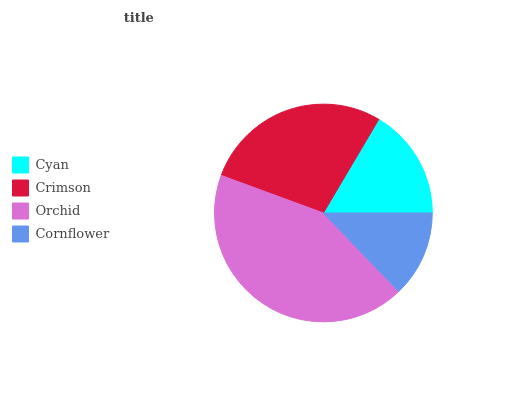Is Cornflower the minimum?
Answer yes or no. Yes. Is Orchid the maximum?
Answer yes or no. Yes. Is Crimson the minimum?
Answer yes or no. No. Is Crimson the maximum?
Answer yes or no. No. Is Crimson greater than Cyan?
Answer yes or no. Yes. Is Cyan less than Crimson?
Answer yes or no. Yes. Is Cyan greater than Crimson?
Answer yes or no. No. Is Crimson less than Cyan?
Answer yes or no. No. Is Crimson the high median?
Answer yes or no. Yes. Is Cyan the low median?
Answer yes or no. Yes. Is Cornflower the high median?
Answer yes or no. No. Is Cornflower the low median?
Answer yes or no. No. 